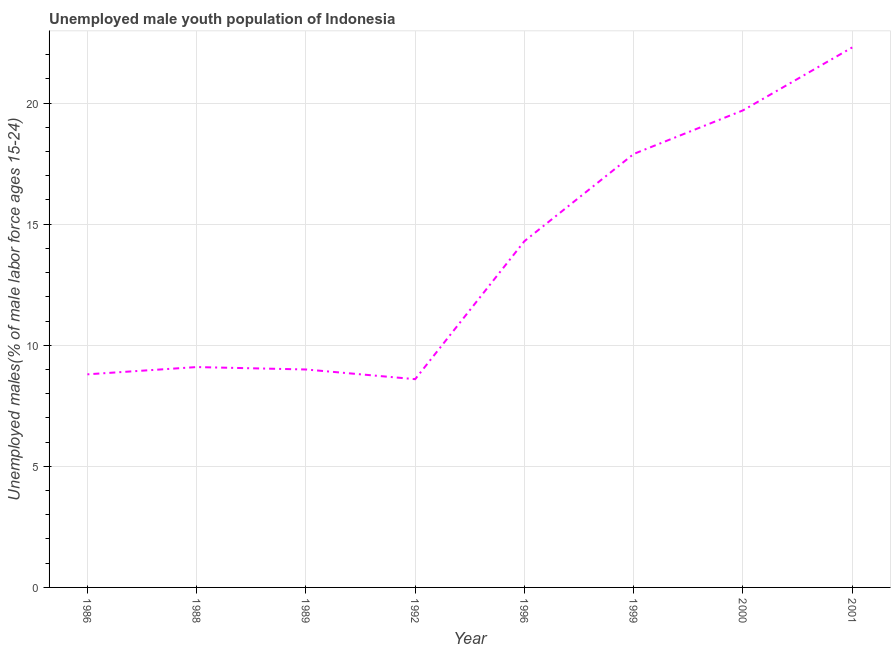What is the unemployed male youth in 1999?
Offer a very short reply. 17.9. Across all years, what is the maximum unemployed male youth?
Offer a very short reply. 22.3. Across all years, what is the minimum unemployed male youth?
Your answer should be compact. 8.6. In which year was the unemployed male youth maximum?
Provide a short and direct response. 2001. What is the sum of the unemployed male youth?
Provide a short and direct response. 109.7. What is the difference between the unemployed male youth in 1986 and 1992?
Your response must be concise. 0.2. What is the average unemployed male youth per year?
Provide a succinct answer. 13.71. What is the median unemployed male youth?
Offer a terse response. 11.7. In how many years, is the unemployed male youth greater than 16 %?
Ensure brevity in your answer.  3. What is the ratio of the unemployed male youth in 1992 to that in 2001?
Give a very brief answer. 0.39. Is the unemployed male youth in 1992 less than that in 2000?
Your answer should be compact. Yes. Is the difference between the unemployed male youth in 1996 and 1999 greater than the difference between any two years?
Your response must be concise. No. What is the difference between the highest and the second highest unemployed male youth?
Make the answer very short. 2.6. What is the difference between the highest and the lowest unemployed male youth?
Your answer should be compact. 13.7. In how many years, is the unemployed male youth greater than the average unemployed male youth taken over all years?
Provide a short and direct response. 4. Does the unemployed male youth monotonically increase over the years?
Keep it short and to the point. No. What is the difference between two consecutive major ticks on the Y-axis?
Your answer should be compact. 5. Does the graph contain grids?
Your answer should be very brief. Yes. What is the title of the graph?
Make the answer very short. Unemployed male youth population of Indonesia. What is the label or title of the Y-axis?
Keep it short and to the point. Unemployed males(% of male labor force ages 15-24). What is the Unemployed males(% of male labor force ages 15-24) in 1986?
Your answer should be compact. 8.8. What is the Unemployed males(% of male labor force ages 15-24) of 1988?
Keep it short and to the point. 9.1. What is the Unemployed males(% of male labor force ages 15-24) in 1992?
Make the answer very short. 8.6. What is the Unemployed males(% of male labor force ages 15-24) in 1996?
Provide a succinct answer. 14.3. What is the Unemployed males(% of male labor force ages 15-24) of 1999?
Provide a succinct answer. 17.9. What is the Unemployed males(% of male labor force ages 15-24) of 2000?
Make the answer very short. 19.7. What is the Unemployed males(% of male labor force ages 15-24) in 2001?
Provide a succinct answer. 22.3. What is the difference between the Unemployed males(% of male labor force ages 15-24) in 1986 and 2001?
Provide a succinct answer. -13.5. What is the difference between the Unemployed males(% of male labor force ages 15-24) in 1988 and 1992?
Give a very brief answer. 0.5. What is the difference between the Unemployed males(% of male labor force ages 15-24) in 1988 and 1996?
Your response must be concise. -5.2. What is the difference between the Unemployed males(% of male labor force ages 15-24) in 1988 and 2000?
Offer a very short reply. -10.6. What is the difference between the Unemployed males(% of male labor force ages 15-24) in 1988 and 2001?
Provide a succinct answer. -13.2. What is the difference between the Unemployed males(% of male labor force ages 15-24) in 1989 and 1992?
Your response must be concise. 0.4. What is the difference between the Unemployed males(% of male labor force ages 15-24) in 1989 and 1996?
Ensure brevity in your answer.  -5.3. What is the difference between the Unemployed males(% of male labor force ages 15-24) in 1989 and 2001?
Keep it short and to the point. -13.3. What is the difference between the Unemployed males(% of male labor force ages 15-24) in 1992 and 1999?
Your answer should be compact. -9.3. What is the difference between the Unemployed males(% of male labor force ages 15-24) in 1992 and 2001?
Provide a short and direct response. -13.7. What is the difference between the Unemployed males(% of male labor force ages 15-24) in 1996 and 2000?
Make the answer very short. -5.4. What is the ratio of the Unemployed males(% of male labor force ages 15-24) in 1986 to that in 1988?
Offer a very short reply. 0.97. What is the ratio of the Unemployed males(% of male labor force ages 15-24) in 1986 to that in 1996?
Offer a terse response. 0.61. What is the ratio of the Unemployed males(% of male labor force ages 15-24) in 1986 to that in 1999?
Your response must be concise. 0.49. What is the ratio of the Unemployed males(% of male labor force ages 15-24) in 1986 to that in 2000?
Provide a short and direct response. 0.45. What is the ratio of the Unemployed males(% of male labor force ages 15-24) in 1986 to that in 2001?
Provide a succinct answer. 0.4. What is the ratio of the Unemployed males(% of male labor force ages 15-24) in 1988 to that in 1989?
Keep it short and to the point. 1.01. What is the ratio of the Unemployed males(% of male labor force ages 15-24) in 1988 to that in 1992?
Your response must be concise. 1.06. What is the ratio of the Unemployed males(% of male labor force ages 15-24) in 1988 to that in 1996?
Give a very brief answer. 0.64. What is the ratio of the Unemployed males(% of male labor force ages 15-24) in 1988 to that in 1999?
Offer a terse response. 0.51. What is the ratio of the Unemployed males(% of male labor force ages 15-24) in 1988 to that in 2000?
Your answer should be compact. 0.46. What is the ratio of the Unemployed males(% of male labor force ages 15-24) in 1988 to that in 2001?
Keep it short and to the point. 0.41. What is the ratio of the Unemployed males(% of male labor force ages 15-24) in 1989 to that in 1992?
Your answer should be very brief. 1.05. What is the ratio of the Unemployed males(% of male labor force ages 15-24) in 1989 to that in 1996?
Offer a very short reply. 0.63. What is the ratio of the Unemployed males(% of male labor force ages 15-24) in 1989 to that in 1999?
Your response must be concise. 0.5. What is the ratio of the Unemployed males(% of male labor force ages 15-24) in 1989 to that in 2000?
Ensure brevity in your answer.  0.46. What is the ratio of the Unemployed males(% of male labor force ages 15-24) in 1989 to that in 2001?
Your answer should be very brief. 0.4. What is the ratio of the Unemployed males(% of male labor force ages 15-24) in 1992 to that in 1996?
Make the answer very short. 0.6. What is the ratio of the Unemployed males(% of male labor force ages 15-24) in 1992 to that in 1999?
Offer a very short reply. 0.48. What is the ratio of the Unemployed males(% of male labor force ages 15-24) in 1992 to that in 2000?
Offer a very short reply. 0.44. What is the ratio of the Unemployed males(% of male labor force ages 15-24) in 1992 to that in 2001?
Make the answer very short. 0.39. What is the ratio of the Unemployed males(% of male labor force ages 15-24) in 1996 to that in 1999?
Give a very brief answer. 0.8. What is the ratio of the Unemployed males(% of male labor force ages 15-24) in 1996 to that in 2000?
Ensure brevity in your answer.  0.73. What is the ratio of the Unemployed males(% of male labor force ages 15-24) in 1996 to that in 2001?
Your answer should be very brief. 0.64. What is the ratio of the Unemployed males(% of male labor force ages 15-24) in 1999 to that in 2000?
Offer a very short reply. 0.91. What is the ratio of the Unemployed males(% of male labor force ages 15-24) in 1999 to that in 2001?
Your answer should be compact. 0.8. What is the ratio of the Unemployed males(% of male labor force ages 15-24) in 2000 to that in 2001?
Provide a succinct answer. 0.88. 